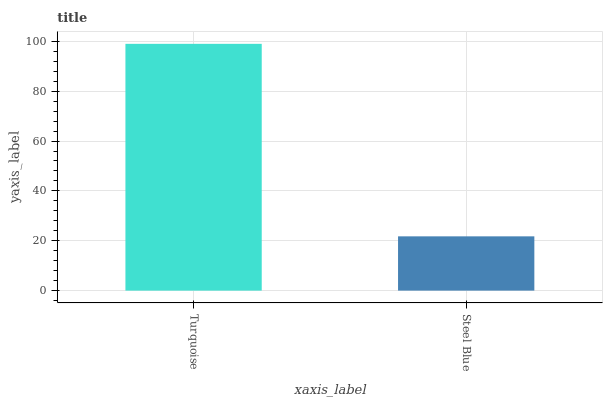Is Steel Blue the minimum?
Answer yes or no. Yes. Is Turquoise the maximum?
Answer yes or no. Yes. Is Steel Blue the maximum?
Answer yes or no. No. Is Turquoise greater than Steel Blue?
Answer yes or no. Yes. Is Steel Blue less than Turquoise?
Answer yes or no. Yes. Is Steel Blue greater than Turquoise?
Answer yes or no. No. Is Turquoise less than Steel Blue?
Answer yes or no. No. Is Turquoise the high median?
Answer yes or no. Yes. Is Steel Blue the low median?
Answer yes or no. Yes. Is Steel Blue the high median?
Answer yes or no. No. Is Turquoise the low median?
Answer yes or no. No. 